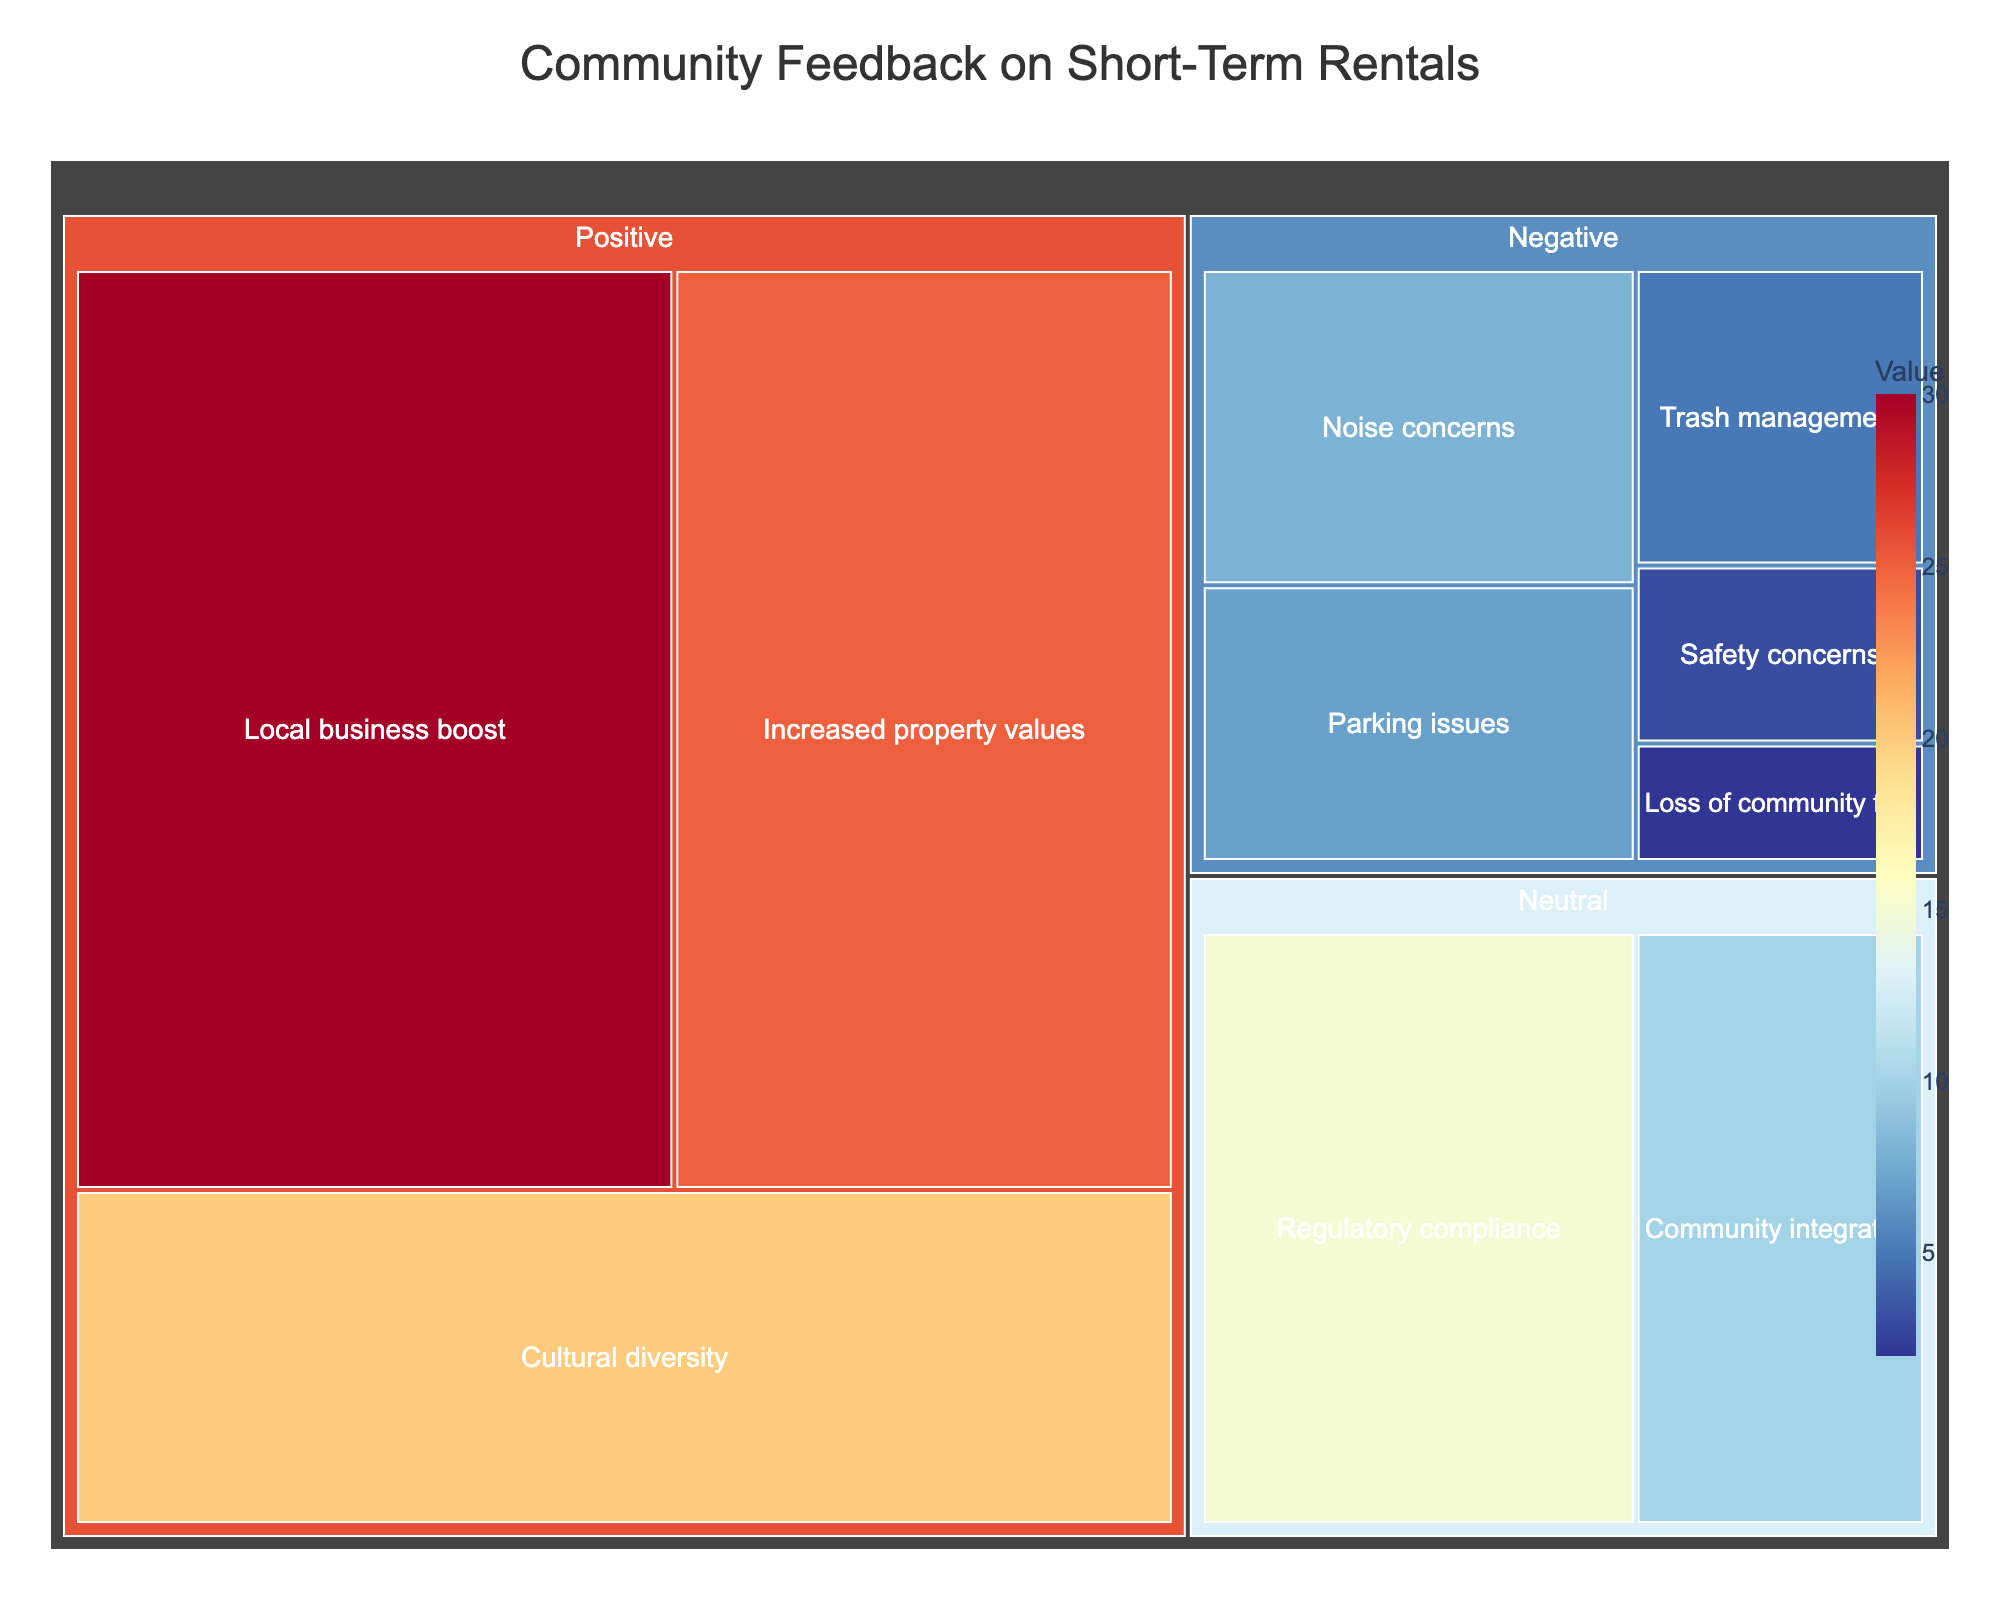What's the title of the treemap? The title of the treemap is displayed at the top of the figure, centrally aligned.
Answer: Community Feedback on Short-Term Rentals How many feedback categories are present in the treemap? By looking at the colors and labels, we can see there are three main categories: Positive, Neutral, and Negative.
Answer: 3 Which sentiment category has the largest value in the treemap? By summing up the values of each subcategory within the sentiment, Positive feedback has the largest total value.
Answer: Positive What's the smallest subcategory in terms of value, and which sentiment does it belong to? "Loss of community feel" has a value of 2 and is the smallest subcategory. It belongs to the Negative sentiment.
Answer: Loss of community feel, Negative What are the values of 'Local business boost' and 'Noise concerns'? By locating 'Local business boost' in the Positive category and 'Noise concerns' in the Negative category, we can see their respective values.
Answer: 30 and 8 What's the difference in value between 'Increased property values' and 'Parking issues'? Find the values for 'Increased property values' (25) and 'Parking issues' (7), and subtract the latter from the former.
Answer: 18 What is the combined value of all negative feedback subcategories? Add all values under Negative: 8 (Noise concerns) + 7 (Parking issues) + 5 (Trash management) + 3 (Safety concerns) + 2 (Loss of community feel) = 25
Answer: 25 Which subcategory has a higher value: 'Regulatory compliance' or 'Cultural diversity'? By comparing the values, 'Regulatory compliance' has a value of 15 and 'Cultural diversity' has a value of 20.
Answer: Cultural diversity If the value of 'Community integration' doubled, what would be its new value, and would it change its rank among the Neutral subcategories? Doubling the value of 'Community integration' (10) would make it 20. Comparing it to 'Regulatory compliance' (15), its rank would change to first place in the Neutral category.
Answer: 20, yes What's the most common feedback subcategory under the Positive sentiment based on value? From Positive subcategories, 'Local business boost' has the highest value of 30, making it the most common feedback.
Answer: Local business boost 